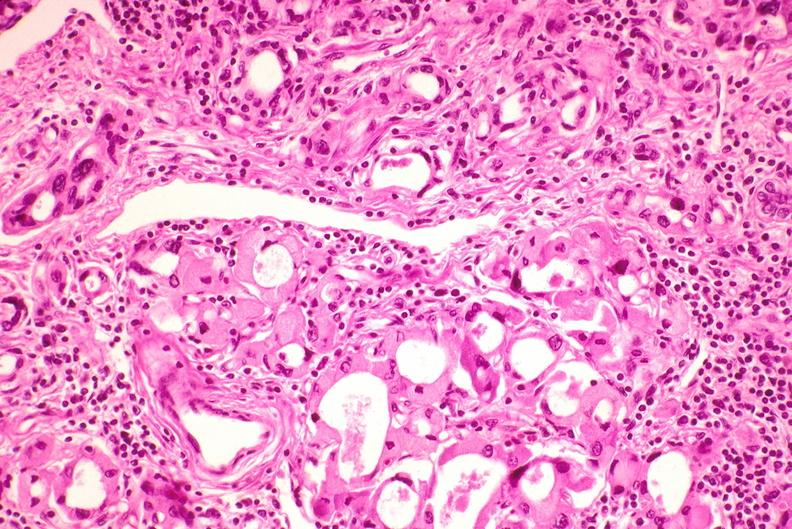what does this image show?
Answer the question using a single word or phrase. Thyroid 